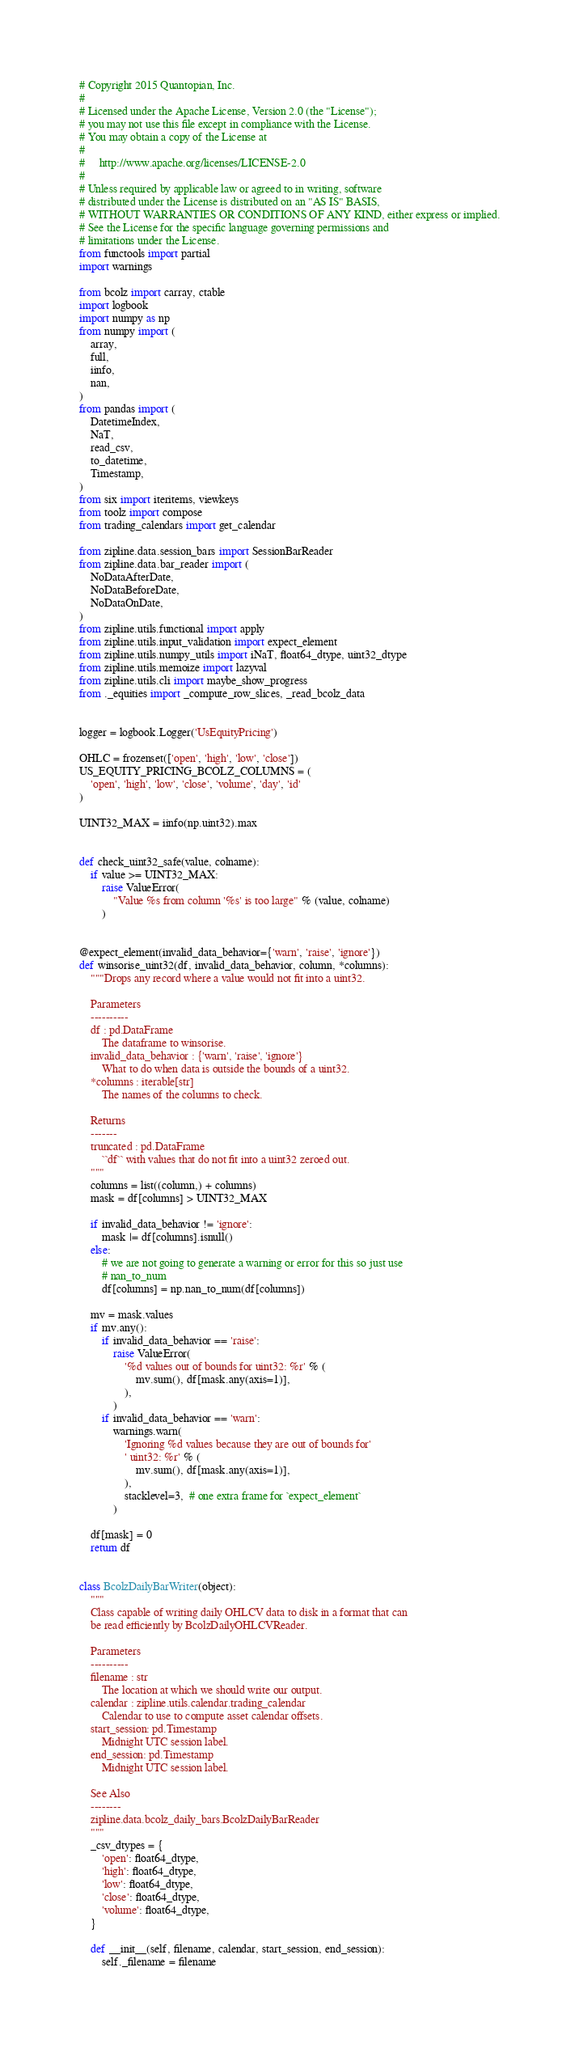Convert code to text. <code><loc_0><loc_0><loc_500><loc_500><_Python_># Copyright 2015 Quantopian, Inc.
#
# Licensed under the Apache License, Version 2.0 (the "License");
# you may not use this file except in compliance with the License.
# You may obtain a copy of the License at
#
#     http://www.apache.org/licenses/LICENSE-2.0
#
# Unless required by applicable law or agreed to in writing, software
# distributed under the License is distributed on an "AS IS" BASIS,
# WITHOUT WARRANTIES OR CONDITIONS OF ANY KIND, either express or implied.
# See the License for the specific language governing permissions and
# limitations under the License.
from functools import partial
import warnings

from bcolz import carray, ctable
import logbook
import numpy as np
from numpy import (
    array,
    full,
    iinfo,
    nan,
)
from pandas import (
    DatetimeIndex,
    NaT,
    read_csv,
    to_datetime,
    Timestamp,
)
from six import iteritems, viewkeys
from toolz import compose
from trading_calendars import get_calendar

from zipline.data.session_bars import SessionBarReader
from zipline.data.bar_reader import (
    NoDataAfterDate,
    NoDataBeforeDate,
    NoDataOnDate,
)
from zipline.utils.functional import apply
from zipline.utils.input_validation import expect_element
from zipline.utils.numpy_utils import iNaT, float64_dtype, uint32_dtype
from zipline.utils.memoize import lazyval
from zipline.utils.cli import maybe_show_progress
from ._equities import _compute_row_slices, _read_bcolz_data


logger = logbook.Logger('UsEquityPricing')

OHLC = frozenset(['open', 'high', 'low', 'close'])
US_EQUITY_PRICING_BCOLZ_COLUMNS = (
    'open', 'high', 'low', 'close', 'volume', 'day', 'id'
)

UINT32_MAX = iinfo(np.uint32).max


def check_uint32_safe(value, colname):
    if value >= UINT32_MAX:
        raise ValueError(
            "Value %s from column '%s' is too large" % (value, colname)
        )


@expect_element(invalid_data_behavior={'warn', 'raise', 'ignore'})
def winsorise_uint32(df, invalid_data_behavior, column, *columns):
    """Drops any record where a value would not fit into a uint32.

    Parameters
    ----------
    df : pd.DataFrame
        The dataframe to winsorise.
    invalid_data_behavior : {'warn', 'raise', 'ignore'}
        What to do when data is outside the bounds of a uint32.
    *columns : iterable[str]
        The names of the columns to check.

    Returns
    -------
    truncated : pd.DataFrame
        ``df`` with values that do not fit into a uint32 zeroed out.
    """
    columns = list((column,) + columns)
    mask = df[columns] > UINT32_MAX

    if invalid_data_behavior != 'ignore':
        mask |= df[columns].isnull()
    else:
        # we are not going to generate a warning or error for this so just use
        # nan_to_num
        df[columns] = np.nan_to_num(df[columns])

    mv = mask.values
    if mv.any():
        if invalid_data_behavior == 'raise':
            raise ValueError(
                '%d values out of bounds for uint32: %r' % (
                    mv.sum(), df[mask.any(axis=1)],
                ),
            )
        if invalid_data_behavior == 'warn':
            warnings.warn(
                'Ignoring %d values because they are out of bounds for'
                ' uint32: %r' % (
                    mv.sum(), df[mask.any(axis=1)],
                ),
                stacklevel=3,  # one extra frame for `expect_element`
            )

    df[mask] = 0
    return df


class BcolzDailyBarWriter(object):
    """
    Class capable of writing daily OHLCV data to disk in a format that can
    be read efficiently by BcolzDailyOHLCVReader.

    Parameters
    ----------
    filename : str
        The location at which we should write our output.
    calendar : zipline.utils.calendar.trading_calendar
        Calendar to use to compute asset calendar offsets.
    start_session: pd.Timestamp
        Midnight UTC session label.
    end_session: pd.Timestamp
        Midnight UTC session label.

    See Also
    --------
    zipline.data.bcolz_daily_bars.BcolzDailyBarReader
    """
    _csv_dtypes = {
        'open': float64_dtype,
        'high': float64_dtype,
        'low': float64_dtype,
        'close': float64_dtype,
        'volume': float64_dtype,
    }

    def __init__(self, filename, calendar, start_session, end_session):
        self._filename = filename
</code> 